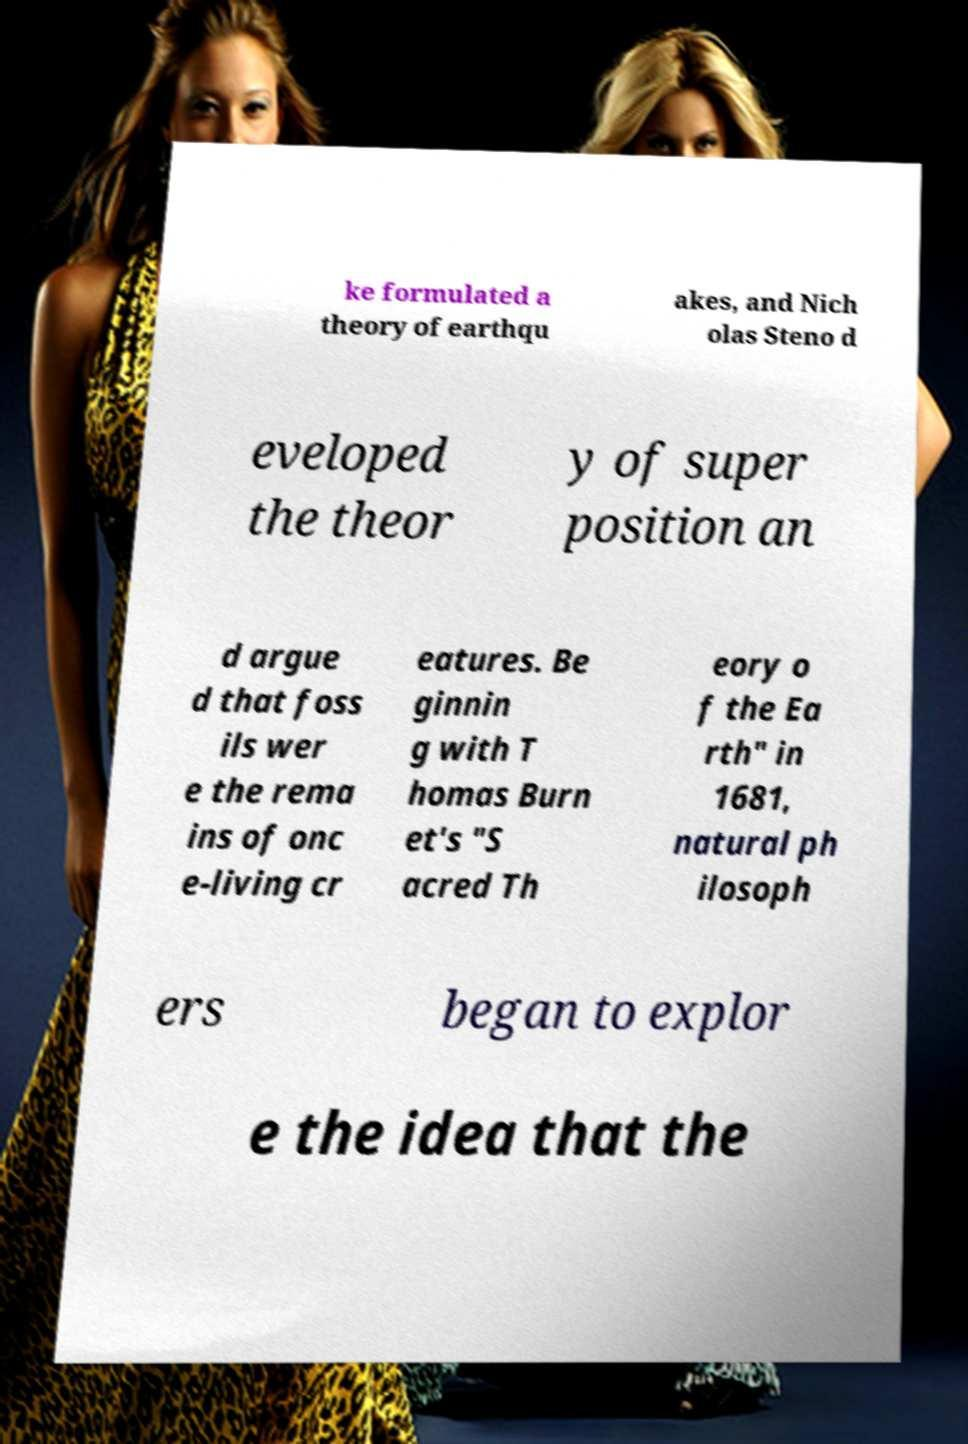Can you accurately transcribe the text from the provided image for me? ke formulated a theory of earthqu akes, and Nich olas Steno d eveloped the theor y of super position an d argue d that foss ils wer e the rema ins of onc e-living cr eatures. Be ginnin g with T homas Burn et's "S acred Th eory o f the Ea rth" in 1681, natural ph ilosoph ers began to explor e the idea that the 